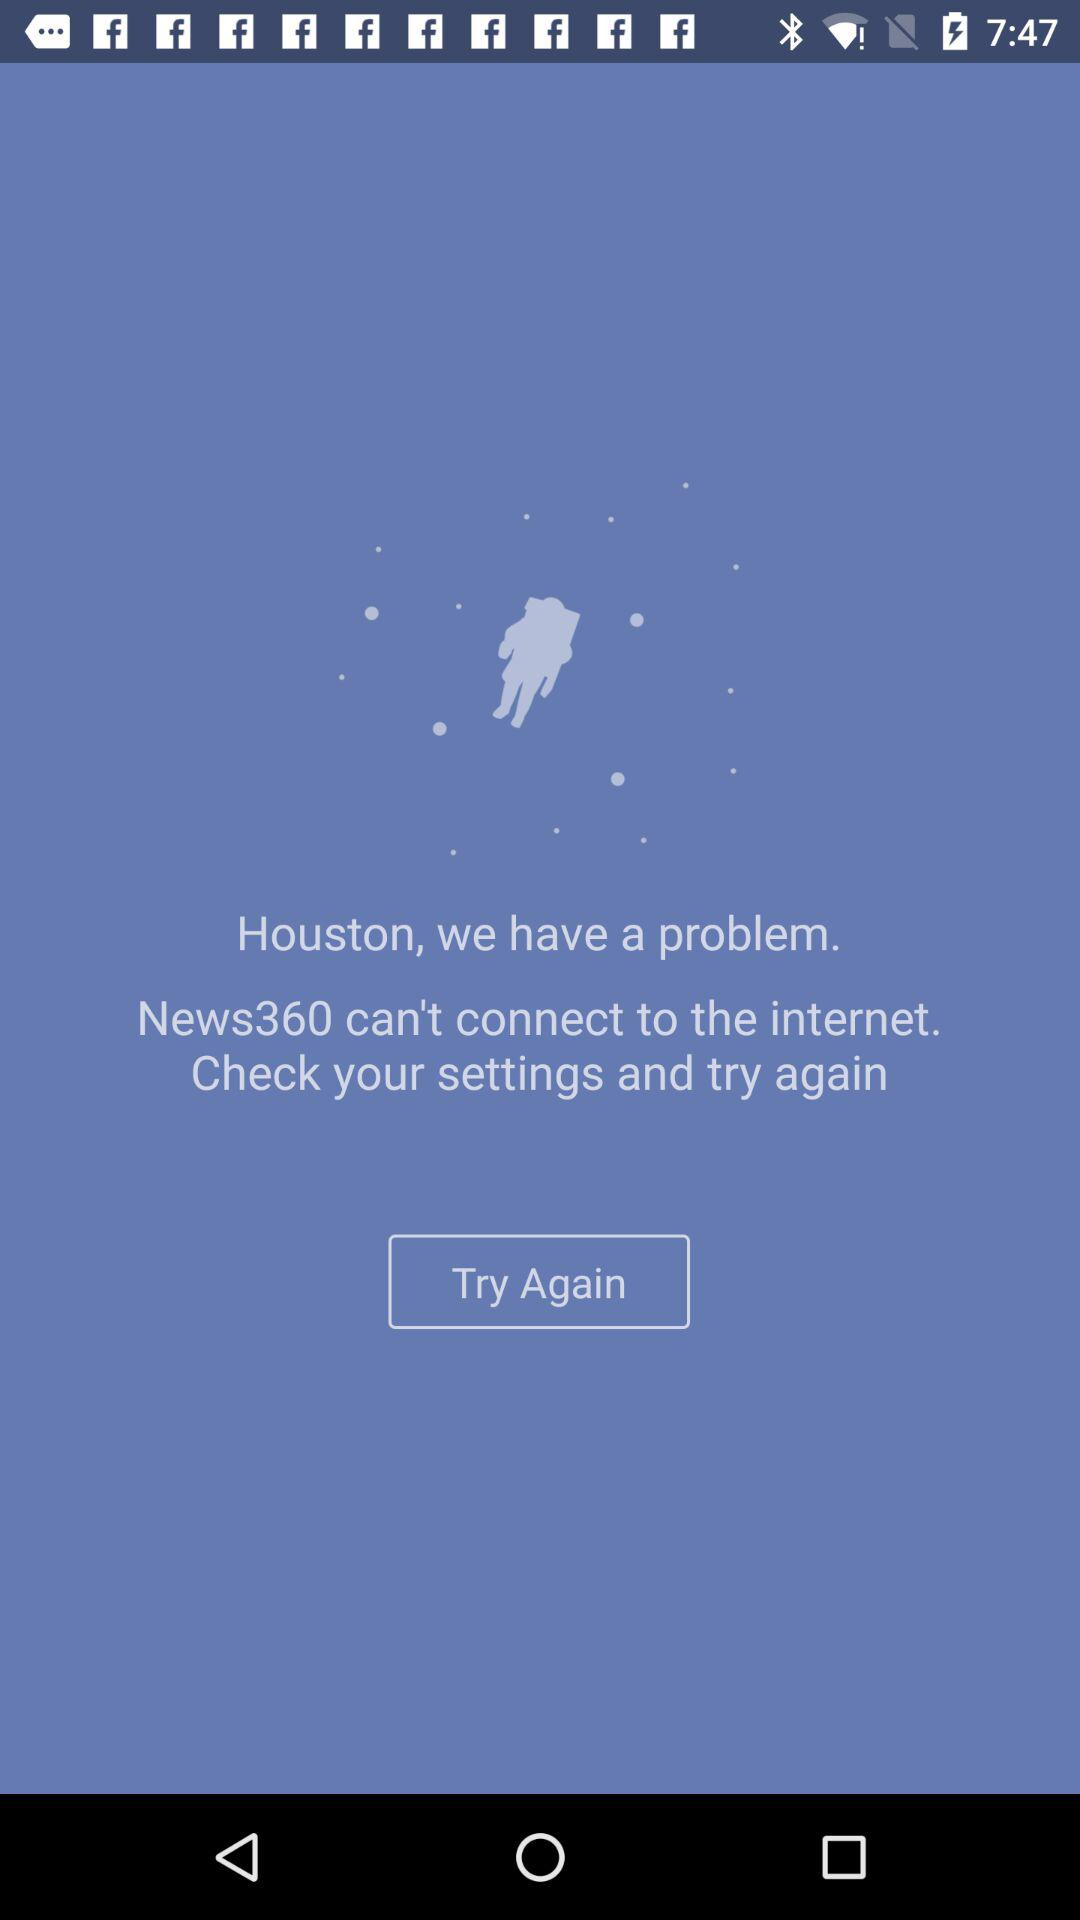What is the name of the news channel? The name of the news channel is "News360". 